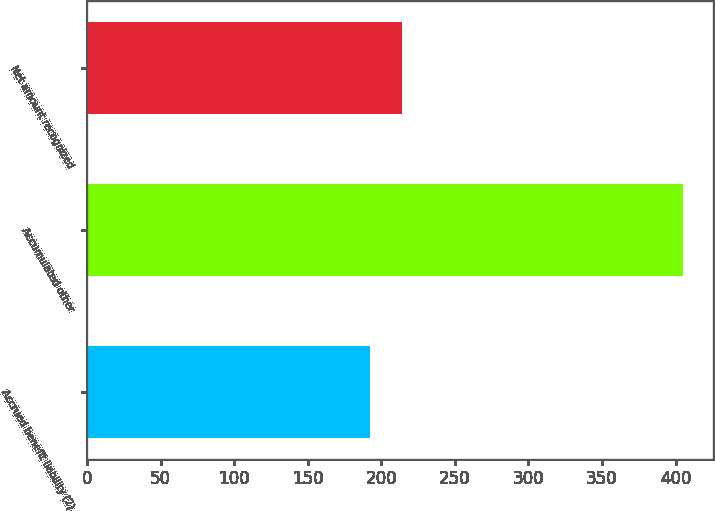Convert chart to OTSL. <chart><loc_0><loc_0><loc_500><loc_500><bar_chart><fcel>Accrued benefit liability (2)<fcel>Accumulated other<fcel>Net amount recognized<nl><fcel>192<fcel>405<fcel>214<nl></chart> 